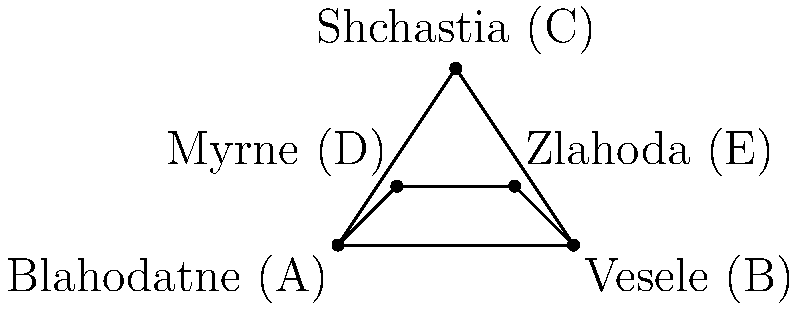A new bus line is being planned to connect Blahodatne with nearby towns. The map shows the distances between towns in kilometers. What is the shortest route that passes through all towns exactly once and returns to Blahodatne? List the towns in the order they should be visited. To find the shortest route, we need to consider all possible paths that visit each town once and return to Blahodatne. This is known as the Traveling Salesman Problem. For a small number of towns, we can solve this by examining all possibilities:

1. Calculate the distances between towns:
   AB = 4, AC = $\sqrt{13}$, AD = $\sqrt{2}$, AE = $\sqrt{10}$
   BC = 3, BD = $\sqrt{10}$, BE = 2
   CD = $\sqrt{5}$, CE = $\sqrt{5}$
   DE = 2

2. List all possible routes (starting and ending at A):
   A-B-C-D-E-A
   A-B-C-E-D-A
   A-B-D-C-E-A
   A-B-D-E-C-A
   A-B-E-C-D-A
   A-B-E-D-C-A
   (and their reverses)

3. Calculate the length of each route:
   A-B-C-D-E-A: 4 + 3 + $\sqrt{5}$ + 2 + $\sqrt{10}$ ≈ 12.86
   A-B-C-E-D-A: 4 + 3 + $\sqrt{5}$ + 2 + $\sqrt{2}$ ≈ 11.65
   A-B-D-C-E-A: 4 + $\sqrt{10}$ + $\sqrt{5}$ + $\sqrt{5}$ + $\sqrt{10}$ ≈ 13.47
   A-B-D-E-C-A: 4 + $\sqrt{10}$ + 2 + $\sqrt{5}$ + $\sqrt{13}$ ≈ 13.20
   A-B-E-C-D-A: 4 + 2 + $\sqrt{5}$ + $\sqrt{5}$ + $\sqrt{2}$ ≈ 11.65
   A-B-E-D-C-A: 4 + 2 + 2 + $\sqrt{5}$ + $\sqrt{13}$ ≈ 12.79

4. The shortest route is either A-B-C-E-D-A or A-B-E-C-D-A, both with a length of approximately 11.65 km.

5. For familiarity and ease of navigation, we choose the route that follows the outer perimeter of the map: A-B-C-E-D-A.
Answer: Blahodatne-Vesele-Shchastia-Zlahoda-Myrne-Blahodatne 